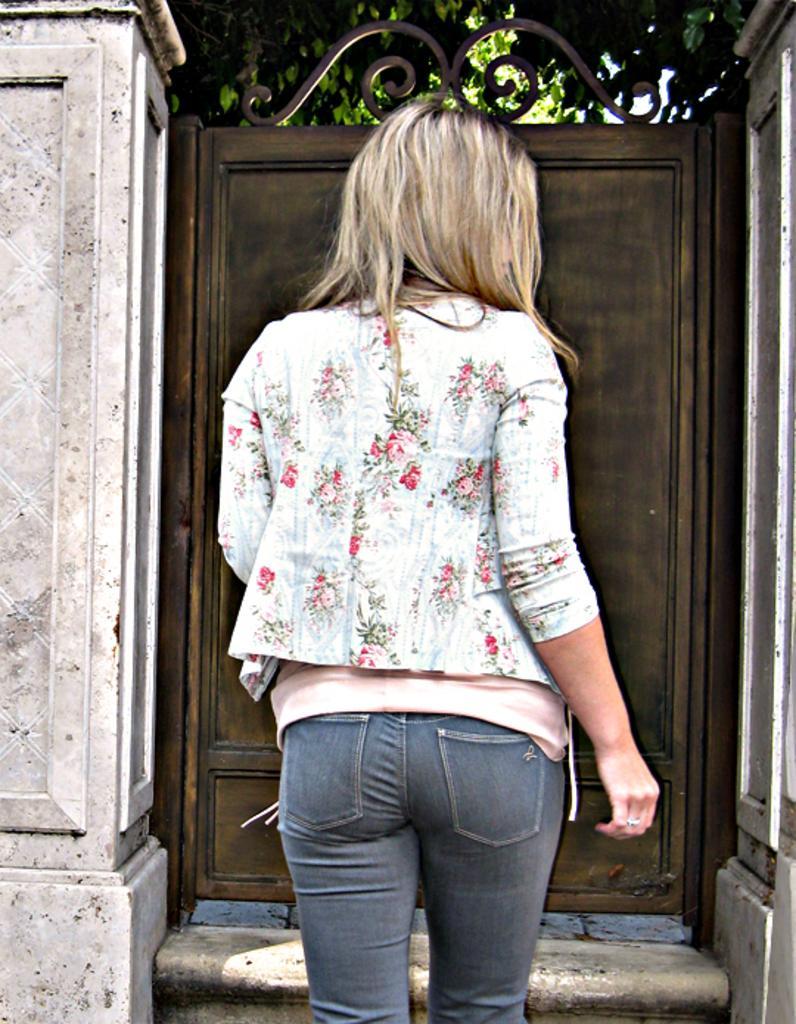How would you summarize this image in a sentence or two? In the image there is a woman walking towards the gate, there are two pillars on the both sides of the gate and there is a tree behind the gate. 